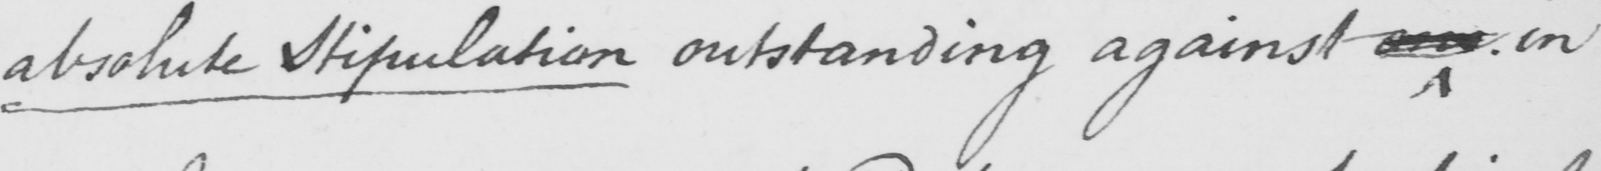What text is written in this handwritten line? absolute stipulation outstanding against one in 